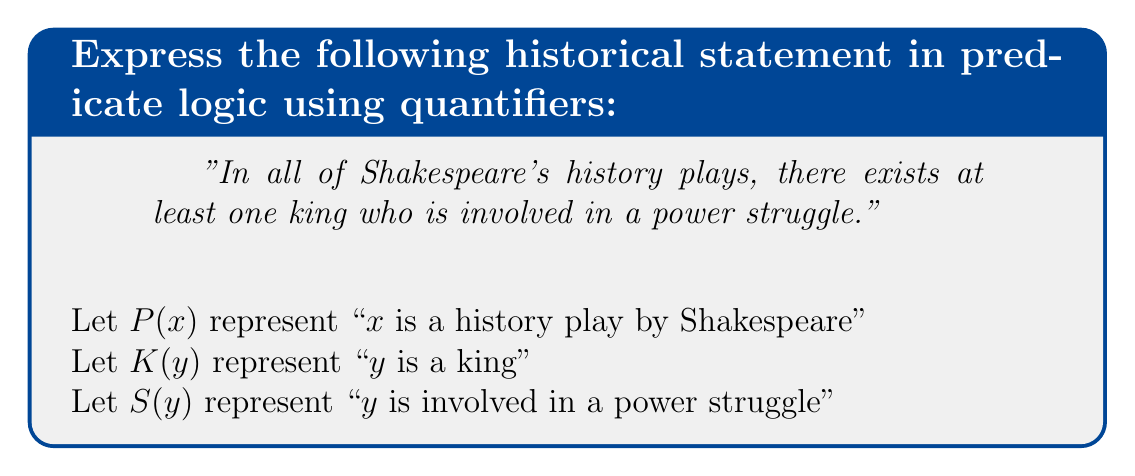Give your solution to this math problem. To express this statement in predicate logic, we need to break it down into its components and use appropriate quantifiers:

1. "In all of Shakespeare's history plays" - This requires a universal quantifier (∀) for the plays.

2. "there exists at least one king" - This requires an existential quantifier (∃) for the king.

3. "who is involved in a power struggle" - This is a property of the king, represented by the predicate S(y).

4. The connection between the play and the king is implicit, so we need to introduce a relation. Let's use $I(x,y)$ to represent "y is a character in x".

Now, we can construct the logical statement step by step:

Step 1: For all plays x that are Shakespeare's history plays:
$$\forall x (P(x) \rightarrow ...)$$

Step 2: There exists a y such that y is a king and y is a character in x:
$$\forall x (P(x) \rightarrow \exists y (K(y) \land I(x,y) \land ...))$$

Step 3: This y is involved in a power struggle:
$$\forall x (P(x) \rightarrow \exists y (K(y) \land I(x,y) \land S(y)))$$

This completes the logical expression of the given statement.
Answer: $$\forall x (P(x) \rightarrow \exists y (K(y) \land I(x,y) \land S(y)))$$ 